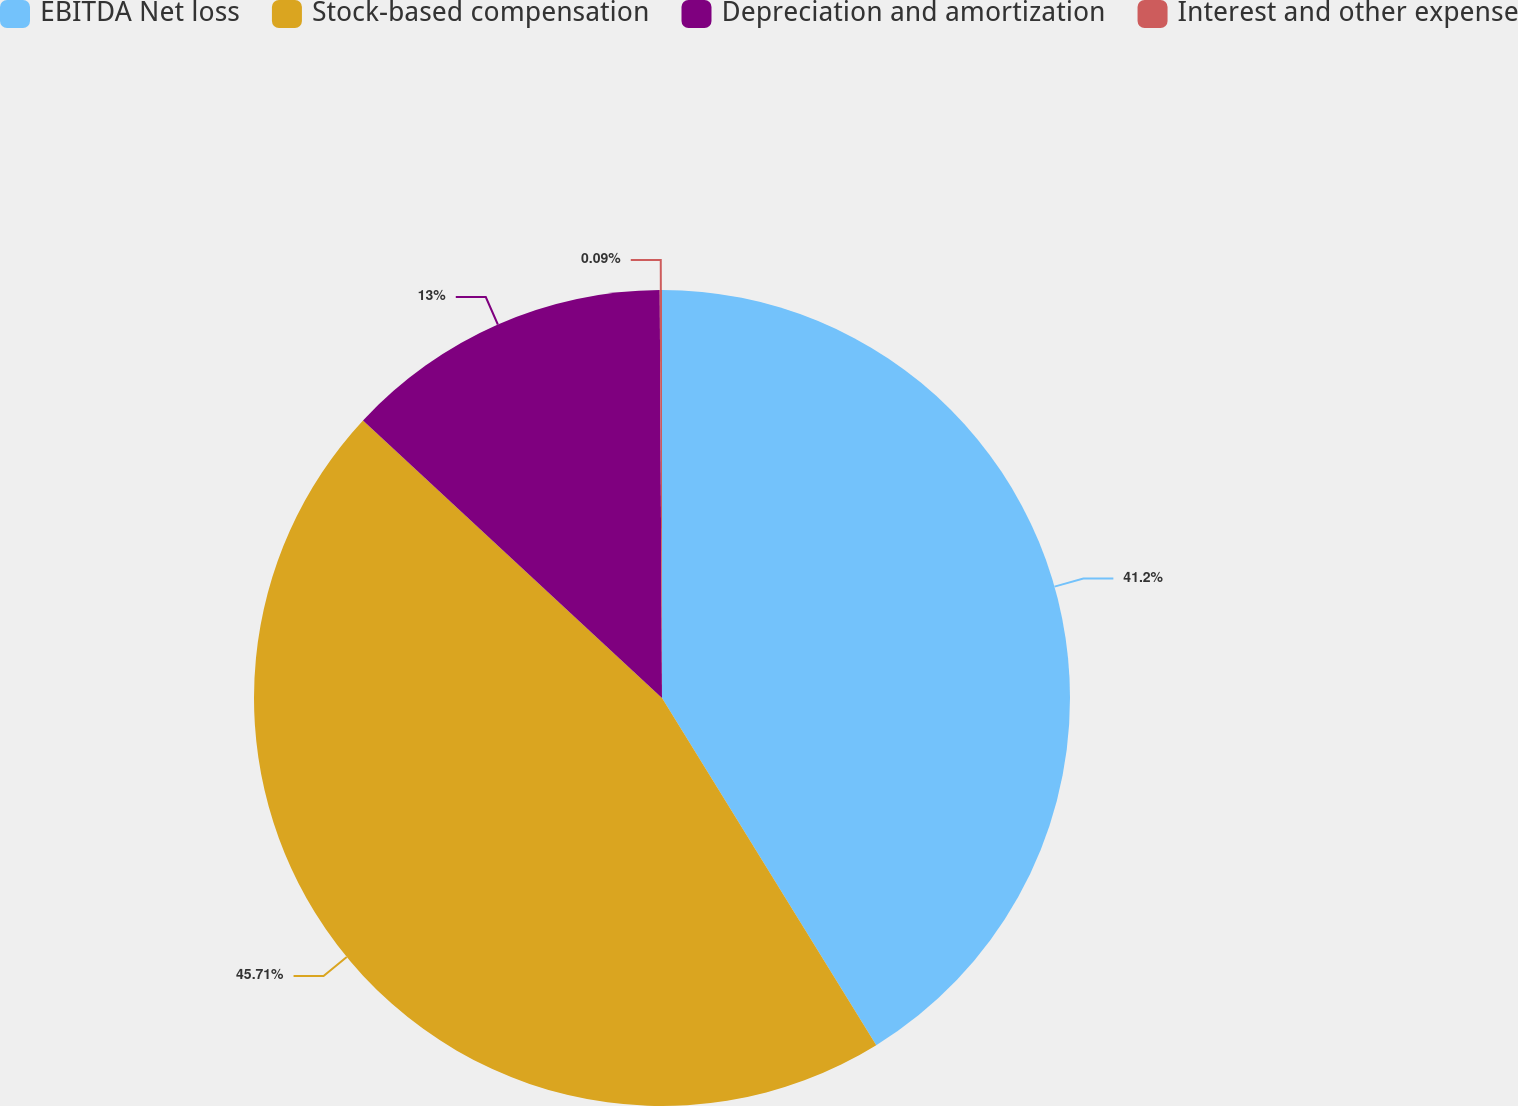Convert chart. <chart><loc_0><loc_0><loc_500><loc_500><pie_chart><fcel>EBITDA Net loss<fcel>Stock-based compensation<fcel>Depreciation and amortization<fcel>Interest and other expense<nl><fcel>41.2%<fcel>45.71%<fcel>13.0%<fcel>0.09%<nl></chart> 